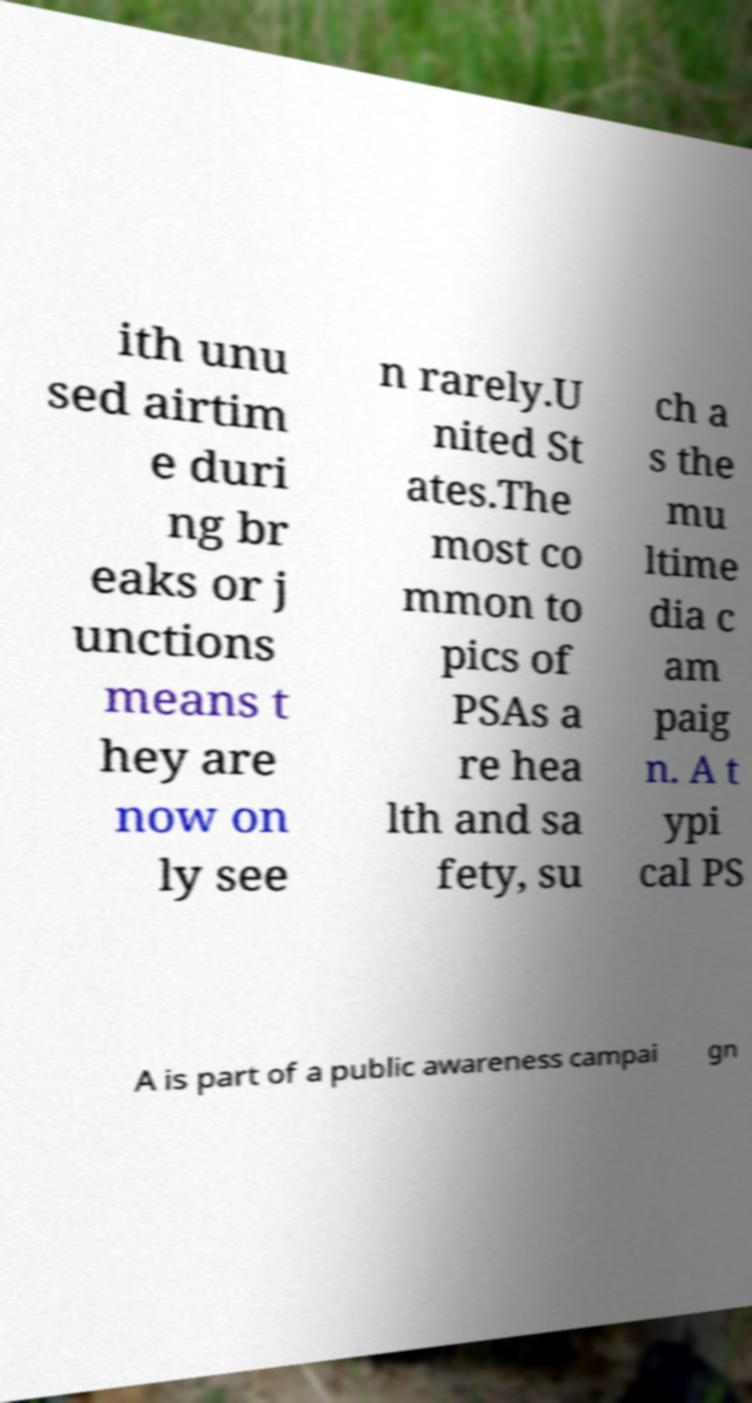Please identify and transcribe the text found in this image. ith unu sed airtim e duri ng br eaks or j unctions means t hey are now on ly see n rarely.U nited St ates.The most co mmon to pics of PSAs a re hea lth and sa fety, su ch a s the mu ltime dia c am paig n. A t ypi cal PS A is part of a public awareness campai gn 